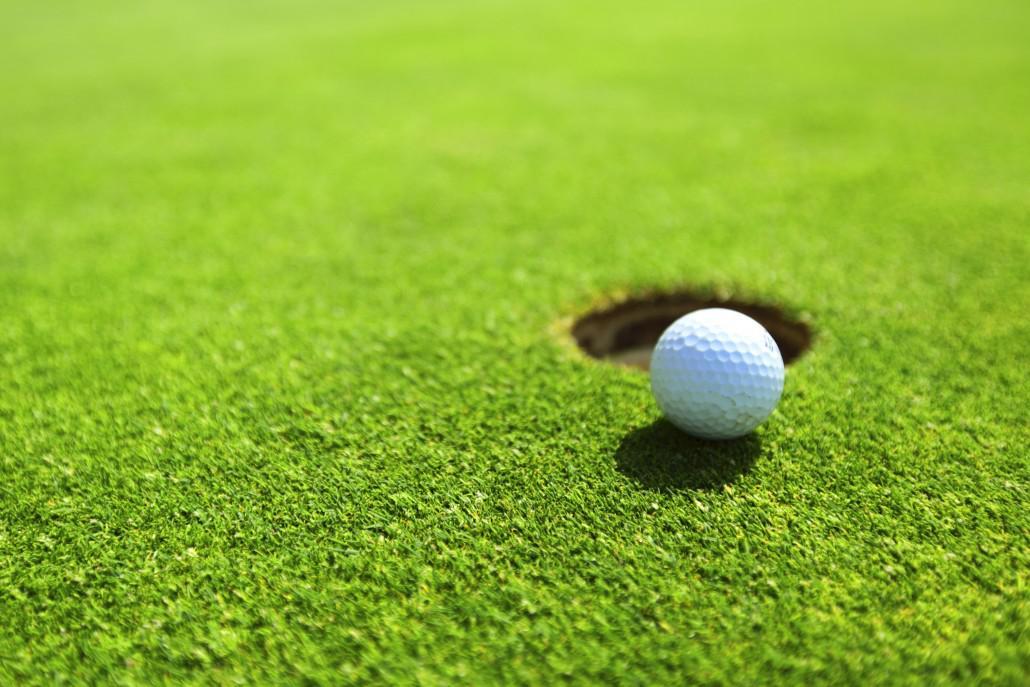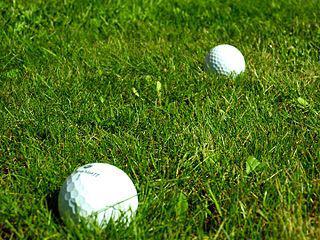The first image is the image on the left, the second image is the image on the right. Considering the images on both sides, is "There are three golf balls, one on the left and two on the right, and no people." valid? Answer yes or no. Yes. The first image is the image on the left, the second image is the image on the right. For the images shown, is this caption "At least one golf ball is within about six inches of a hole with a pole sticking out of it." true? Answer yes or no. No. 